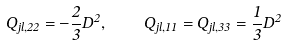Convert formula to latex. <formula><loc_0><loc_0><loc_500><loc_500>Q _ { j l , 2 2 } = - \frac { 2 } { 3 } D ^ { 2 } , \quad Q _ { j l , 1 1 } = Q _ { j l , 3 3 } = \frac { 1 } { 3 } D ^ { 2 }</formula> 